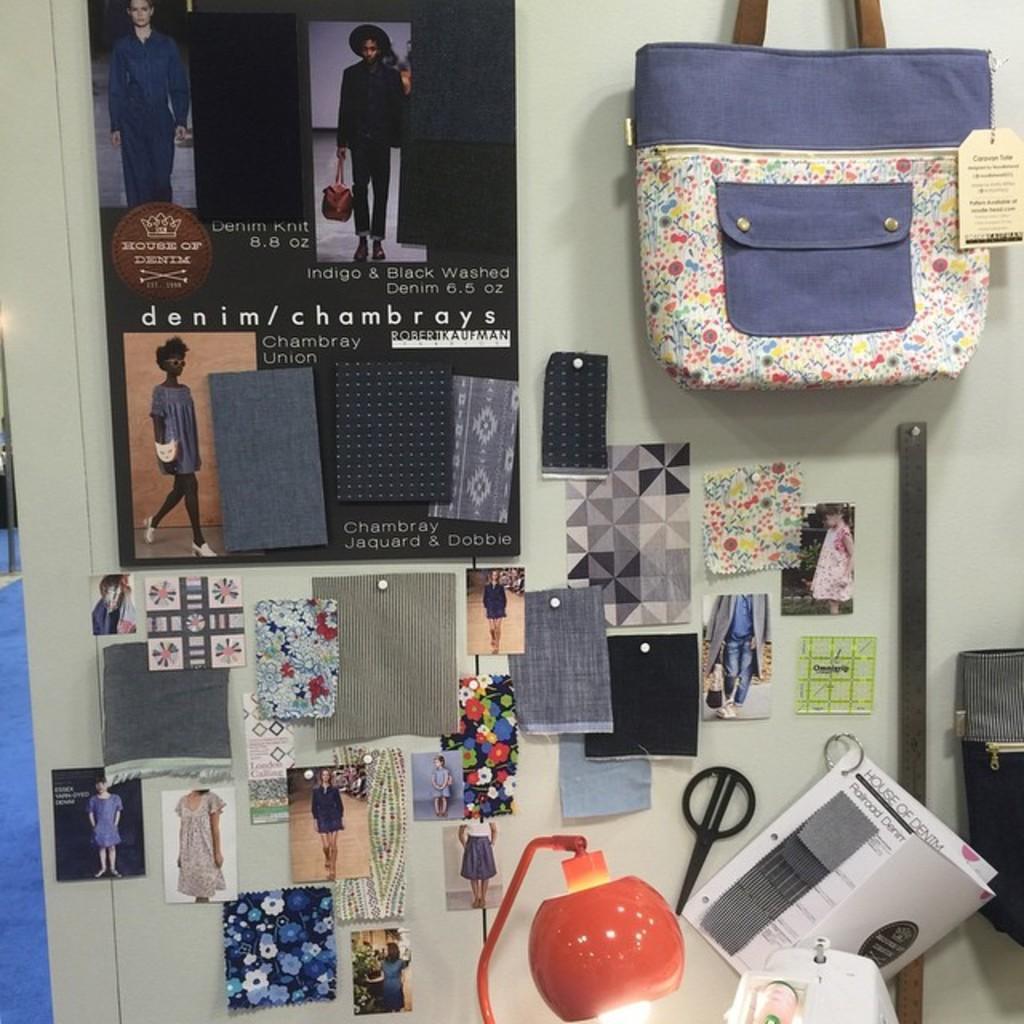Can you describe this image briefly? In this image I can see a poster, few photos and handbag on this wall. I can also see a lamp and few papers. 